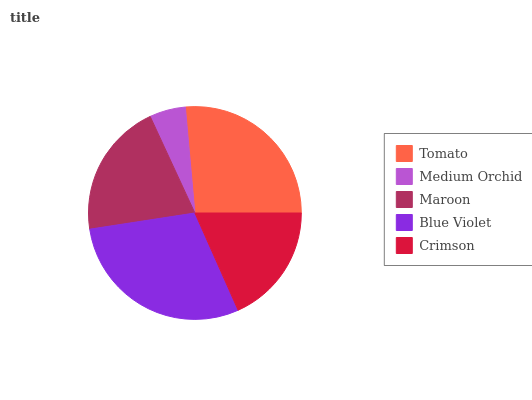Is Medium Orchid the minimum?
Answer yes or no. Yes. Is Blue Violet the maximum?
Answer yes or no. Yes. Is Maroon the minimum?
Answer yes or no. No. Is Maroon the maximum?
Answer yes or no. No. Is Maroon greater than Medium Orchid?
Answer yes or no. Yes. Is Medium Orchid less than Maroon?
Answer yes or no. Yes. Is Medium Orchid greater than Maroon?
Answer yes or no. No. Is Maroon less than Medium Orchid?
Answer yes or no. No. Is Maroon the high median?
Answer yes or no. Yes. Is Maroon the low median?
Answer yes or no. Yes. Is Tomato the high median?
Answer yes or no. No. Is Tomato the low median?
Answer yes or no. No. 